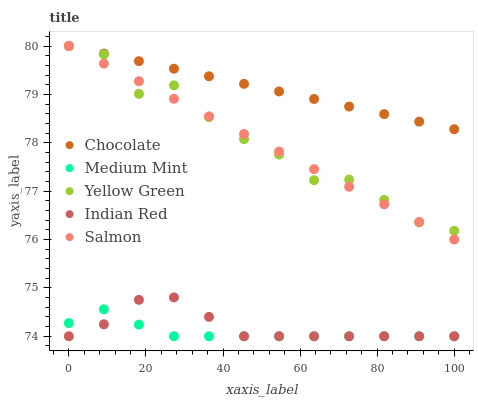Does Medium Mint have the minimum area under the curve?
Answer yes or no. Yes. Does Chocolate have the maximum area under the curve?
Answer yes or no. Yes. Does Salmon have the minimum area under the curve?
Answer yes or no. No. Does Salmon have the maximum area under the curve?
Answer yes or no. No. Is Chocolate the smoothest?
Answer yes or no. Yes. Is Yellow Green the roughest?
Answer yes or no. Yes. Is Salmon the smoothest?
Answer yes or no. No. Is Salmon the roughest?
Answer yes or no. No. Does Medium Mint have the lowest value?
Answer yes or no. Yes. Does Salmon have the lowest value?
Answer yes or no. No. Does Chocolate have the highest value?
Answer yes or no. Yes. Does Indian Red have the highest value?
Answer yes or no. No. Is Medium Mint less than Chocolate?
Answer yes or no. Yes. Is Salmon greater than Indian Red?
Answer yes or no. Yes. Does Yellow Green intersect Chocolate?
Answer yes or no. Yes. Is Yellow Green less than Chocolate?
Answer yes or no. No. Is Yellow Green greater than Chocolate?
Answer yes or no. No. Does Medium Mint intersect Chocolate?
Answer yes or no. No. 